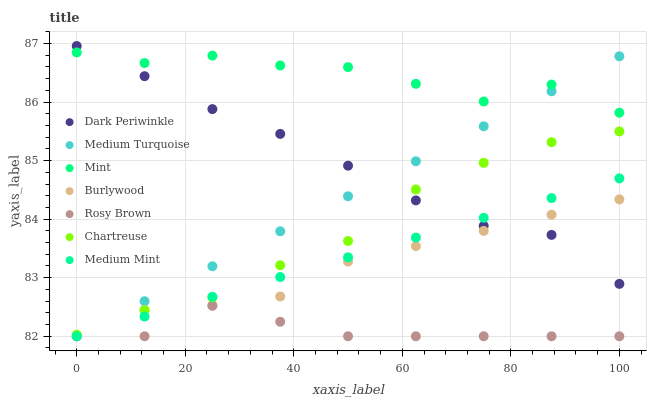Does Rosy Brown have the minimum area under the curve?
Answer yes or no. Yes. Does Mint have the maximum area under the curve?
Answer yes or no. Yes. Does Burlywood have the minimum area under the curve?
Answer yes or no. No. Does Burlywood have the maximum area under the curve?
Answer yes or no. No. Is Medium Mint the smoothest?
Answer yes or no. Yes. Is Mint the roughest?
Answer yes or no. Yes. Is Burlywood the smoothest?
Answer yes or no. No. Is Burlywood the roughest?
Answer yes or no. No. Does Medium Mint have the lowest value?
Answer yes or no. Yes. Does Chartreuse have the lowest value?
Answer yes or no. No. Does Dark Periwinkle have the highest value?
Answer yes or no. Yes. Does Burlywood have the highest value?
Answer yes or no. No. Is Chartreuse less than Mint?
Answer yes or no. Yes. Is Mint greater than Medium Mint?
Answer yes or no. Yes. Does Medium Turquoise intersect Burlywood?
Answer yes or no. Yes. Is Medium Turquoise less than Burlywood?
Answer yes or no. No. Is Medium Turquoise greater than Burlywood?
Answer yes or no. No. Does Chartreuse intersect Mint?
Answer yes or no. No. 